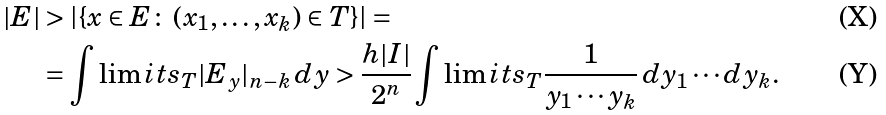Convert formula to latex. <formula><loc_0><loc_0><loc_500><loc_500>| E | & > \left | \left \{ x \in E \colon \, ( x _ { 1 } , \dots , x _ { k } ) \in T \right \} \right | = \\ & = \int \lim i t s _ { T } | E _ { y } | _ { n - k } \, d y > \frac { h | I | } { 2 ^ { n } } \int \lim i t s _ { T } \frac { 1 } { y _ { 1 } \cdots y _ { k } } \, d y _ { 1 } \cdots d y _ { k } .</formula> 